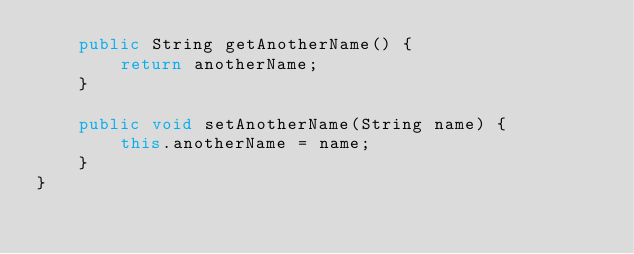Convert code to text. <code><loc_0><loc_0><loc_500><loc_500><_Java_>    public String getAnotherName() {
        return anotherName;
    }

    public void setAnotherName(String name) {
        this.anotherName = name;
    }
}
</code> 